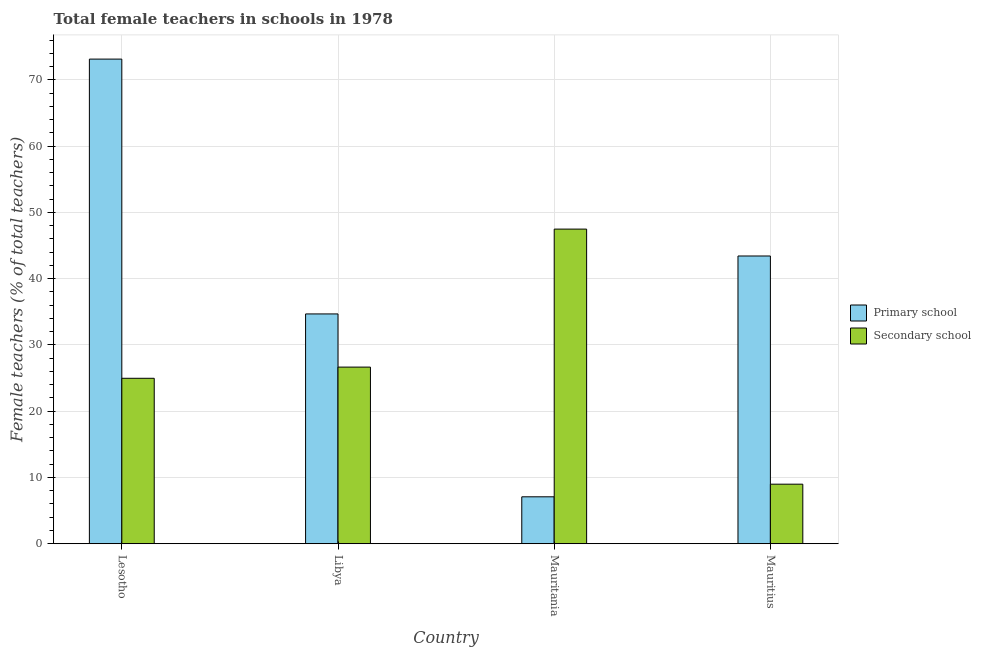How many groups of bars are there?
Provide a succinct answer. 4. How many bars are there on the 2nd tick from the right?
Your answer should be compact. 2. What is the label of the 4th group of bars from the left?
Your answer should be very brief. Mauritius. In how many cases, is the number of bars for a given country not equal to the number of legend labels?
Offer a very short reply. 0. What is the percentage of female teachers in primary schools in Lesotho?
Keep it short and to the point. 73.13. Across all countries, what is the maximum percentage of female teachers in primary schools?
Your response must be concise. 73.13. Across all countries, what is the minimum percentage of female teachers in primary schools?
Ensure brevity in your answer.  7.08. In which country was the percentage of female teachers in primary schools maximum?
Give a very brief answer. Lesotho. In which country was the percentage of female teachers in secondary schools minimum?
Provide a short and direct response. Mauritius. What is the total percentage of female teachers in primary schools in the graph?
Offer a very short reply. 158.31. What is the difference between the percentage of female teachers in primary schools in Lesotho and that in Mauritius?
Your answer should be very brief. 29.71. What is the difference between the percentage of female teachers in primary schools in Libya and the percentage of female teachers in secondary schools in Mauritius?
Provide a succinct answer. 25.69. What is the average percentage of female teachers in secondary schools per country?
Offer a very short reply. 27.02. What is the difference between the percentage of female teachers in secondary schools and percentage of female teachers in primary schools in Mauritius?
Make the answer very short. -34.43. What is the ratio of the percentage of female teachers in secondary schools in Lesotho to that in Libya?
Ensure brevity in your answer.  0.94. Is the percentage of female teachers in primary schools in Lesotho less than that in Mauritania?
Your answer should be compact. No. What is the difference between the highest and the second highest percentage of female teachers in secondary schools?
Ensure brevity in your answer.  20.82. What is the difference between the highest and the lowest percentage of female teachers in secondary schools?
Offer a very short reply. 38.49. Is the sum of the percentage of female teachers in primary schools in Mauritania and Mauritius greater than the maximum percentage of female teachers in secondary schools across all countries?
Make the answer very short. Yes. What does the 2nd bar from the left in Lesotho represents?
Your response must be concise. Secondary school. What does the 2nd bar from the right in Lesotho represents?
Give a very brief answer. Primary school. How many bars are there?
Provide a succinct answer. 8. Are all the bars in the graph horizontal?
Ensure brevity in your answer.  No. How many countries are there in the graph?
Your response must be concise. 4. What is the difference between two consecutive major ticks on the Y-axis?
Your answer should be compact. 10. Does the graph contain any zero values?
Make the answer very short. No. Where does the legend appear in the graph?
Offer a terse response. Center right. How are the legend labels stacked?
Make the answer very short. Vertical. What is the title of the graph?
Give a very brief answer. Total female teachers in schools in 1978. What is the label or title of the X-axis?
Ensure brevity in your answer.  Country. What is the label or title of the Y-axis?
Give a very brief answer. Female teachers (% of total teachers). What is the Female teachers (% of total teachers) of Primary school in Lesotho?
Offer a terse response. 73.13. What is the Female teachers (% of total teachers) of Secondary school in Lesotho?
Ensure brevity in your answer.  24.97. What is the Female teachers (% of total teachers) of Primary school in Libya?
Make the answer very short. 34.68. What is the Female teachers (% of total teachers) in Secondary school in Libya?
Keep it short and to the point. 26.65. What is the Female teachers (% of total teachers) in Primary school in Mauritania?
Make the answer very short. 7.08. What is the Female teachers (% of total teachers) of Secondary school in Mauritania?
Offer a very short reply. 47.48. What is the Female teachers (% of total teachers) of Primary school in Mauritius?
Give a very brief answer. 43.42. What is the Female teachers (% of total teachers) of Secondary school in Mauritius?
Your response must be concise. 8.99. Across all countries, what is the maximum Female teachers (% of total teachers) in Primary school?
Your response must be concise. 73.13. Across all countries, what is the maximum Female teachers (% of total teachers) of Secondary school?
Ensure brevity in your answer.  47.48. Across all countries, what is the minimum Female teachers (% of total teachers) in Primary school?
Make the answer very short. 7.08. Across all countries, what is the minimum Female teachers (% of total teachers) in Secondary school?
Offer a very short reply. 8.99. What is the total Female teachers (% of total teachers) of Primary school in the graph?
Provide a succinct answer. 158.31. What is the total Female teachers (% of total teachers) in Secondary school in the graph?
Provide a succinct answer. 108.09. What is the difference between the Female teachers (% of total teachers) of Primary school in Lesotho and that in Libya?
Your response must be concise. 38.45. What is the difference between the Female teachers (% of total teachers) of Secondary school in Lesotho and that in Libya?
Your response must be concise. -1.69. What is the difference between the Female teachers (% of total teachers) in Primary school in Lesotho and that in Mauritania?
Offer a terse response. 66.05. What is the difference between the Female teachers (% of total teachers) of Secondary school in Lesotho and that in Mauritania?
Provide a succinct answer. -22.51. What is the difference between the Female teachers (% of total teachers) in Primary school in Lesotho and that in Mauritius?
Keep it short and to the point. 29.71. What is the difference between the Female teachers (% of total teachers) in Secondary school in Lesotho and that in Mauritius?
Offer a very short reply. 15.98. What is the difference between the Female teachers (% of total teachers) of Primary school in Libya and that in Mauritania?
Offer a very short reply. 27.59. What is the difference between the Female teachers (% of total teachers) of Secondary school in Libya and that in Mauritania?
Offer a terse response. -20.82. What is the difference between the Female teachers (% of total teachers) of Primary school in Libya and that in Mauritius?
Offer a terse response. -8.74. What is the difference between the Female teachers (% of total teachers) in Secondary school in Libya and that in Mauritius?
Make the answer very short. 17.67. What is the difference between the Female teachers (% of total teachers) in Primary school in Mauritania and that in Mauritius?
Provide a succinct answer. -36.34. What is the difference between the Female teachers (% of total teachers) in Secondary school in Mauritania and that in Mauritius?
Give a very brief answer. 38.49. What is the difference between the Female teachers (% of total teachers) of Primary school in Lesotho and the Female teachers (% of total teachers) of Secondary school in Libya?
Give a very brief answer. 46.47. What is the difference between the Female teachers (% of total teachers) of Primary school in Lesotho and the Female teachers (% of total teachers) of Secondary school in Mauritania?
Your answer should be very brief. 25.65. What is the difference between the Female teachers (% of total teachers) in Primary school in Lesotho and the Female teachers (% of total teachers) in Secondary school in Mauritius?
Provide a succinct answer. 64.14. What is the difference between the Female teachers (% of total teachers) of Primary school in Libya and the Female teachers (% of total teachers) of Secondary school in Mauritania?
Make the answer very short. -12.8. What is the difference between the Female teachers (% of total teachers) of Primary school in Libya and the Female teachers (% of total teachers) of Secondary school in Mauritius?
Give a very brief answer. 25.69. What is the difference between the Female teachers (% of total teachers) in Primary school in Mauritania and the Female teachers (% of total teachers) in Secondary school in Mauritius?
Offer a very short reply. -1.91. What is the average Female teachers (% of total teachers) of Primary school per country?
Make the answer very short. 39.58. What is the average Female teachers (% of total teachers) in Secondary school per country?
Offer a terse response. 27.02. What is the difference between the Female teachers (% of total teachers) in Primary school and Female teachers (% of total teachers) in Secondary school in Lesotho?
Keep it short and to the point. 48.16. What is the difference between the Female teachers (% of total teachers) of Primary school and Female teachers (% of total teachers) of Secondary school in Libya?
Provide a short and direct response. 8.02. What is the difference between the Female teachers (% of total teachers) in Primary school and Female teachers (% of total teachers) in Secondary school in Mauritania?
Give a very brief answer. -40.4. What is the difference between the Female teachers (% of total teachers) of Primary school and Female teachers (% of total teachers) of Secondary school in Mauritius?
Make the answer very short. 34.43. What is the ratio of the Female teachers (% of total teachers) of Primary school in Lesotho to that in Libya?
Offer a very short reply. 2.11. What is the ratio of the Female teachers (% of total teachers) in Secondary school in Lesotho to that in Libya?
Provide a succinct answer. 0.94. What is the ratio of the Female teachers (% of total teachers) of Primary school in Lesotho to that in Mauritania?
Provide a short and direct response. 10.33. What is the ratio of the Female teachers (% of total teachers) in Secondary school in Lesotho to that in Mauritania?
Keep it short and to the point. 0.53. What is the ratio of the Female teachers (% of total teachers) in Primary school in Lesotho to that in Mauritius?
Ensure brevity in your answer.  1.68. What is the ratio of the Female teachers (% of total teachers) in Secondary school in Lesotho to that in Mauritius?
Make the answer very short. 2.78. What is the ratio of the Female teachers (% of total teachers) of Primary school in Libya to that in Mauritania?
Make the answer very short. 4.9. What is the ratio of the Female teachers (% of total teachers) of Secondary school in Libya to that in Mauritania?
Your answer should be compact. 0.56. What is the ratio of the Female teachers (% of total teachers) of Primary school in Libya to that in Mauritius?
Keep it short and to the point. 0.8. What is the ratio of the Female teachers (% of total teachers) in Secondary school in Libya to that in Mauritius?
Ensure brevity in your answer.  2.97. What is the ratio of the Female teachers (% of total teachers) in Primary school in Mauritania to that in Mauritius?
Offer a terse response. 0.16. What is the ratio of the Female teachers (% of total teachers) in Secondary school in Mauritania to that in Mauritius?
Give a very brief answer. 5.28. What is the difference between the highest and the second highest Female teachers (% of total teachers) in Primary school?
Make the answer very short. 29.71. What is the difference between the highest and the second highest Female teachers (% of total teachers) of Secondary school?
Ensure brevity in your answer.  20.82. What is the difference between the highest and the lowest Female teachers (% of total teachers) of Primary school?
Keep it short and to the point. 66.05. What is the difference between the highest and the lowest Female teachers (% of total teachers) of Secondary school?
Give a very brief answer. 38.49. 